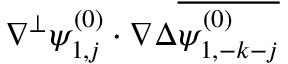<formula> <loc_0><loc_0><loc_500><loc_500>\nabla ^ { \perp } \psi _ { 1 , j } ^ { ( 0 ) } \cdot \nabla \Delta \overline { { \psi _ { 1 , - k - j } ^ { ( 0 ) } } }</formula> 